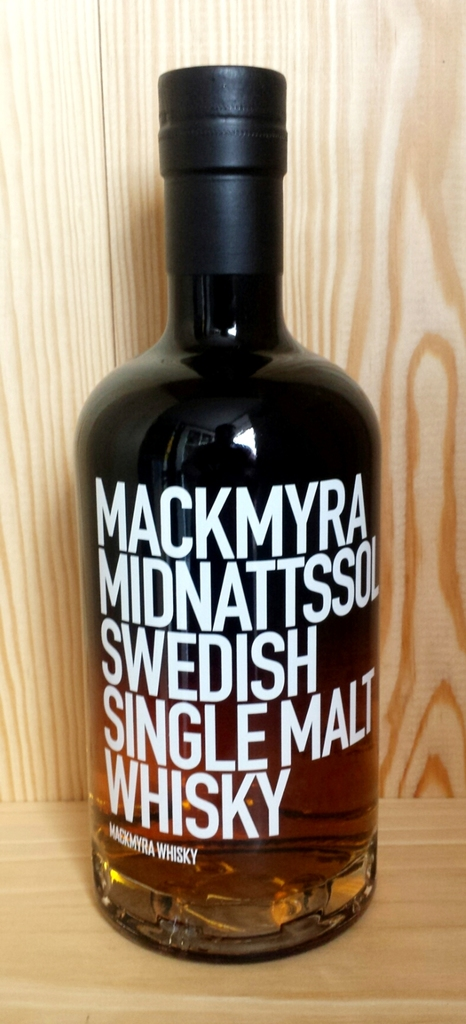How does the packaging of this bottle reflect traditional or modern whisky industry trends? The Mackmyra Midnattssol bottle combines traditional and modern elements in its design. The classic dark bottle and sophisticated typography suggest a premium, traditional product, while the clear, bold text and minimalistic style mirrors contemporary design trends. This blend of old and new appeals to a broad audience, reflecting both the heritage and innovation in the whisky industry. 